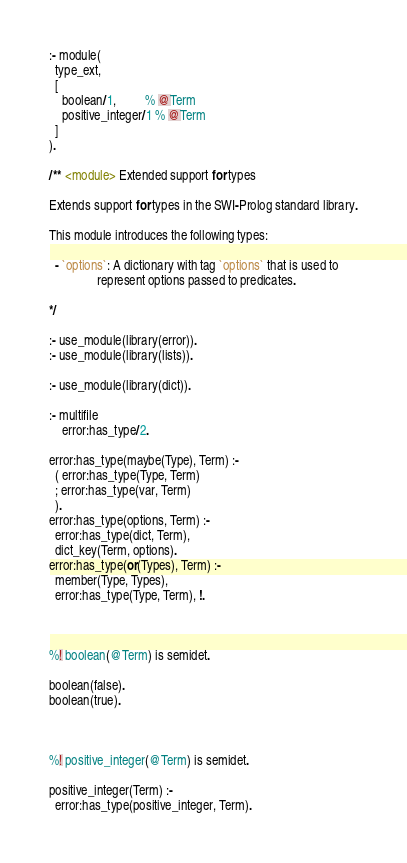Convert code to text. <code><loc_0><loc_0><loc_500><loc_500><_Perl_>:- module(
  type_ext,
  [
    boolean/1,         % @Term
    positive_integer/1 % @Term
  ]
).

/** <module> Extended support for types

Extends support for types in the SWI-Prolog standard library.

This module introduces the following types:

  - `options`: A dictionary with tag `options` that is used to
               represent options passed to predicates.

*/

:- use_module(library(error)).
:- use_module(library(lists)).

:- use_module(library(dict)).

:- multifile
    error:has_type/2.

error:has_type(maybe(Type), Term) :-
  ( error:has_type(Type, Term)
  ; error:has_type(var, Term)
  ).
error:has_type(options, Term) :-
  error:has_type(dict, Term),
  dict_key(Term, options).
error:has_type(or(Types), Term) :-
  member(Type, Types),
  error:has_type(Type, Term), !.



%! boolean(@Term) is semidet.

boolean(false).
boolean(true).



%! positive_integer(@Term) is semidet.

positive_integer(Term) :-
  error:has_type(positive_integer, Term).
</code> 